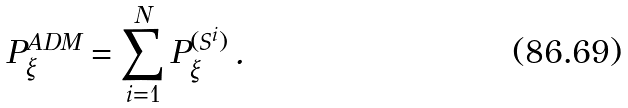<formula> <loc_0><loc_0><loc_500><loc_500>P _ { \xi } ^ { A D M } = \sum _ { i = 1 } ^ { N } P _ { \xi } ^ { ( S ^ { i } ) } \, .</formula> 